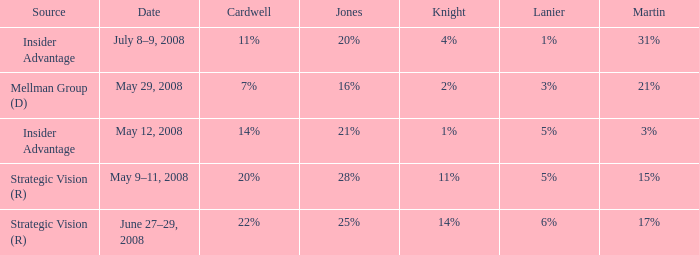What source has a Knight of 2%? Mellman Group (D). 